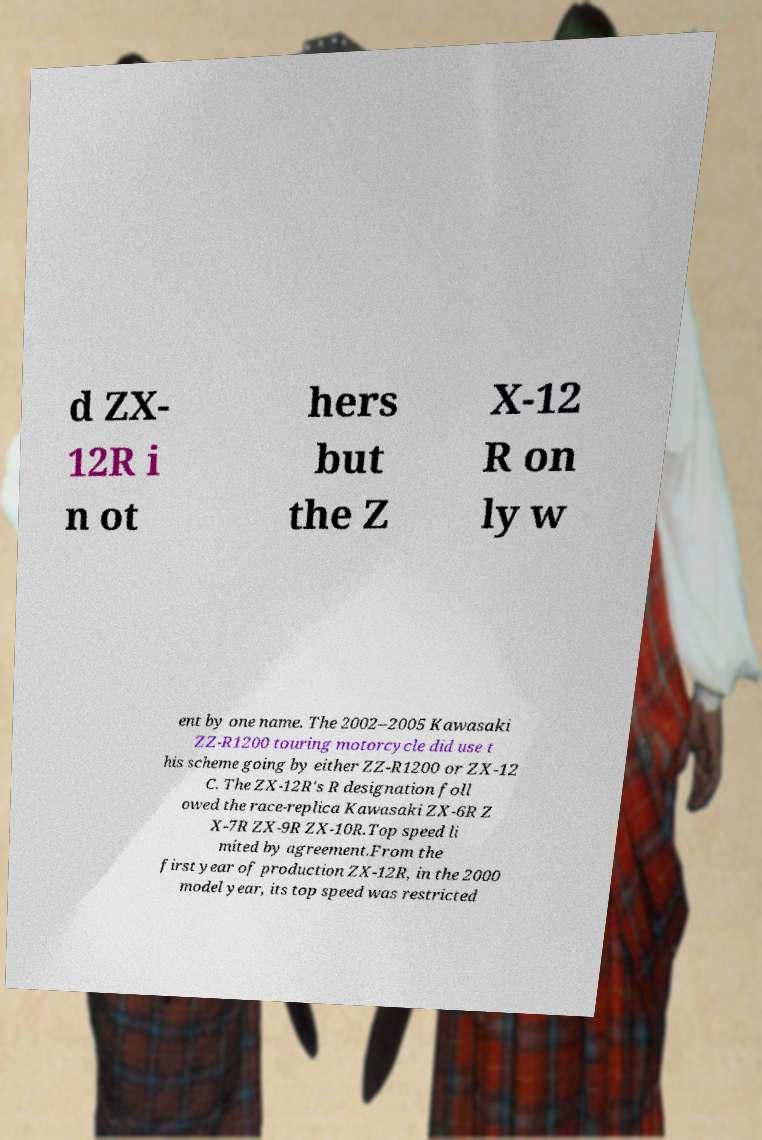What messages or text are displayed in this image? I need them in a readable, typed format. d ZX- 12R i n ot hers but the Z X-12 R on ly w ent by one name. The 2002–2005 Kawasaki ZZ-R1200 touring motorcycle did use t his scheme going by either ZZ-R1200 or ZX-12 C. The ZX-12R's R designation foll owed the race-replica Kawasaki ZX-6R Z X-7R ZX-9R ZX-10R.Top speed li mited by agreement.From the first year of production ZX-12R, in the 2000 model year, its top speed was restricted 